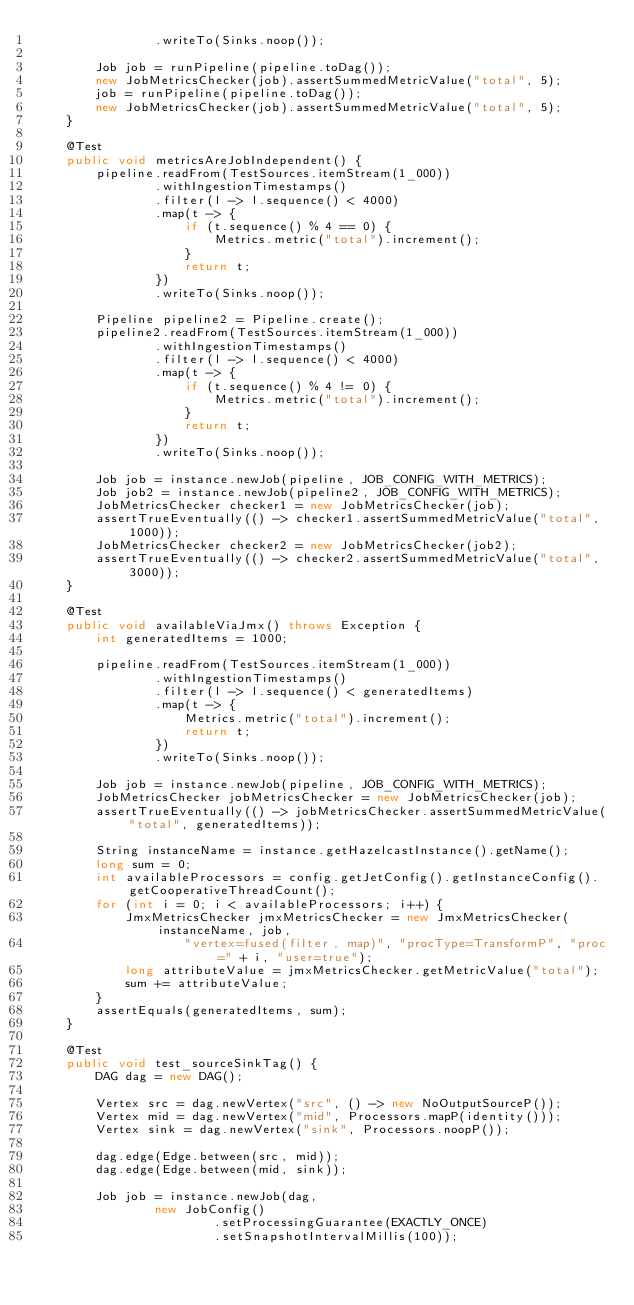Convert code to text. <code><loc_0><loc_0><loc_500><loc_500><_Java_>                .writeTo(Sinks.noop());

        Job job = runPipeline(pipeline.toDag());
        new JobMetricsChecker(job).assertSummedMetricValue("total", 5);
        job = runPipeline(pipeline.toDag());
        new JobMetricsChecker(job).assertSummedMetricValue("total", 5);
    }

    @Test
    public void metricsAreJobIndependent() {
        pipeline.readFrom(TestSources.itemStream(1_000))
                .withIngestionTimestamps()
                .filter(l -> l.sequence() < 4000)
                .map(t -> {
                    if (t.sequence() % 4 == 0) {
                        Metrics.metric("total").increment();
                    }
                    return t;
                })
                .writeTo(Sinks.noop());

        Pipeline pipeline2 = Pipeline.create();
        pipeline2.readFrom(TestSources.itemStream(1_000))
                .withIngestionTimestamps()
                .filter(l -> l.sequence() < 4000)
                .map(t -> {
                    if (t.sequence() % 4 != 0) {
                        Metrics.metric("total").increment();
                    }
                    return t;
                })
                .writeTo(Sinks.noop());

        Job job = instance.newJob(pipeline, JOB_CONFIG_WITH_METRICS);
        Job job2 = instance.newJob(pipeline2, JOB_CONFIG_WITH_METRICS);
        JobMetricsChecker checker1 = new JobMetricsChecker(job);
        assertTrueEventually(() -> checker1.assertSummedMetricValue("total", 1000));
        JobMetricsChecker checker2 = new JobMetricsChecker(job2);
        assertTrueEventually(() -> checker2.assertSummedMetricValue("total", 3000));
    }

    @Test
    public void availableViaJmx() throws Exception {
        int generatedItems = 1000;

        pipeline.readFrom(TestSources.itemStream(1_000))
                .withIngestionTimestamps()
                .filter(l -> l.sequence() < generatedItems)
                .map(t -> {
                    Metrics.metric("total").increment();
                    return t;
                })
                .writeTo(Sinks.noop());

        Job job = instance.newJob(pipeline, JOB_CONFIG_WITH_METRICS);
        JobMetricsChecker jobMetricsChecker = new JobMetricsChecker(job);
        assertTrueEventually(() -> jobMetricsChecker.assertSummedMetricValue("total", generatedItems));

        String instanceName = instance.getHazelcastInstance().getName();
        long sum = 0;
        int availableProcessors = config.getJetConfig().getInstanceConfig().getCooperativeThreadCount();
        for (int i = 0; i < availableProcessors; i++) {
            JmxMetricsChecker jmxMetricsChecker = new JmxMetricsChecker(instanceName, job,
                    "vertex=fused(filter, map)", "procType=TransformP", "proc=" + i, "user=true");
            long attributeValue = jmxMetricsChecker.getMetricValue("total");
            sum += attributeValue;
        }
        assertEquals(generatedItems, sum);
    }

    @Test
    public void test_sourceSinkTag() {
        DAG dag = new DAG();

        Vertex src = dag.newVertex("src", () -> new NoOutputSourceP());
        Vertex mid = dag.newVertex("mid", Processors.mapP(identity()));
        Vertex sink = dag.newVertex("sink", Processors.noopP());

        dag.edge(Edge.between(src, mid));
        dag.edge(Edge.between(mid, sink));

        Job job = instance.newJob(dag,
                new JobConfig()
                        .setProcessingGuarantee(EXACTLY_ONCE)
                        .setSnapshotIntervalMillis(100));</code> 